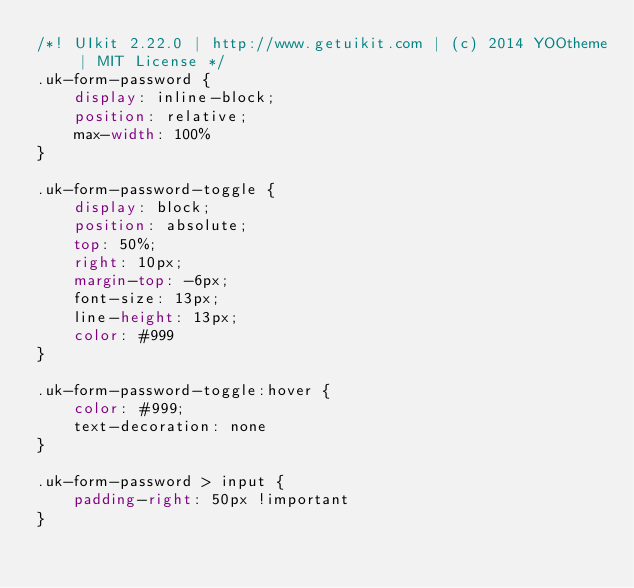Convert code to text. <code><loc_0><loc_0><loc_500><loc_500><_CSS_>/*! UIkit 2.22.0 | http://www.getuikit.com | (c) 2014 YOOtheme | MIT License */
.uk-form-password {
    display: inline-block;
    position: relative;
    max-width: 100%
}

.uk-form-password-toggle {
    display: block;
    position: absolute;
    top: 50%;
    right: 10px;
    margin-top: -6px;
    font-size: 13px;
    line-height: 13px;
    color: #999
}

.uk-form-password-toggle:hover {
    color: #999;
    text-decoration: none
}

.uk-form-password > input {
    padding-right: 50px !important
}</code> 